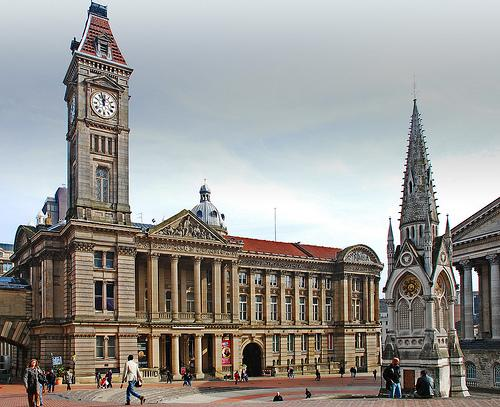As part of a referential expression grounding task, describe an aspect of the image related to the color red. There is a red section on a long roof of a building in the image. List two actions being performed by different individuals in this image. 2. A man sitting down near a steeple on the right For a visual entailment task, provide a statement that is True based on the image. There are four windows on a building near a clock tower. For a product advertisement task, describe a clothing item from the image that could be advertised. Stay stylish and warm with our chic long gray buttoned coat - perfect for strolling through historic cities and blending in with the locals. Made with high-quality materials, this coat offers both fashion and practicality for your adventures. Describe the prominent building feature situated high up on a tower. The prominent building feature is a clock with roman numerals high up on the tower. For a referential expression grounding task, identify the main architectural feature on the right side of the image. The main architectural feature on the right side is a pointy steeple on a small building. Imagine this scene as an advertisement for a travel company. Describe the type of place shown in the image and what a traveler might experience there. Explore a charming cityscape with historic architecture, featuring tall clock towers, intriguing steeples, and ornate monuments. Walk down cobblestone streets alongside locals and admire the stunning buildings with their unique details. Use adjectives and brief details to describe the type of weather shown in the image. The weather in the image is overcast and gray, with clouds covering the blue sky during the day. In a multi-choice VQA task format, provide a question about the building with a clock tower and four potential answers. 3. White clock In a multi-choice VQA task, list four options that could describe a person walking through this scene. 4. Man wearing a black leather jacket 